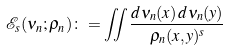Convert formula to latex. <formula><loc_0><loc_0><loc_500><loc_500>\mathcal { E } _ { s } ( \nu _ { n } ; \rho _ { n } ) \colon = \iint \frac { d \nu _ { n } ( x ) \, d \nu _ { n } ( y ) } { \rho _ { n } ( x , y ) ^ { s } }</formula> 